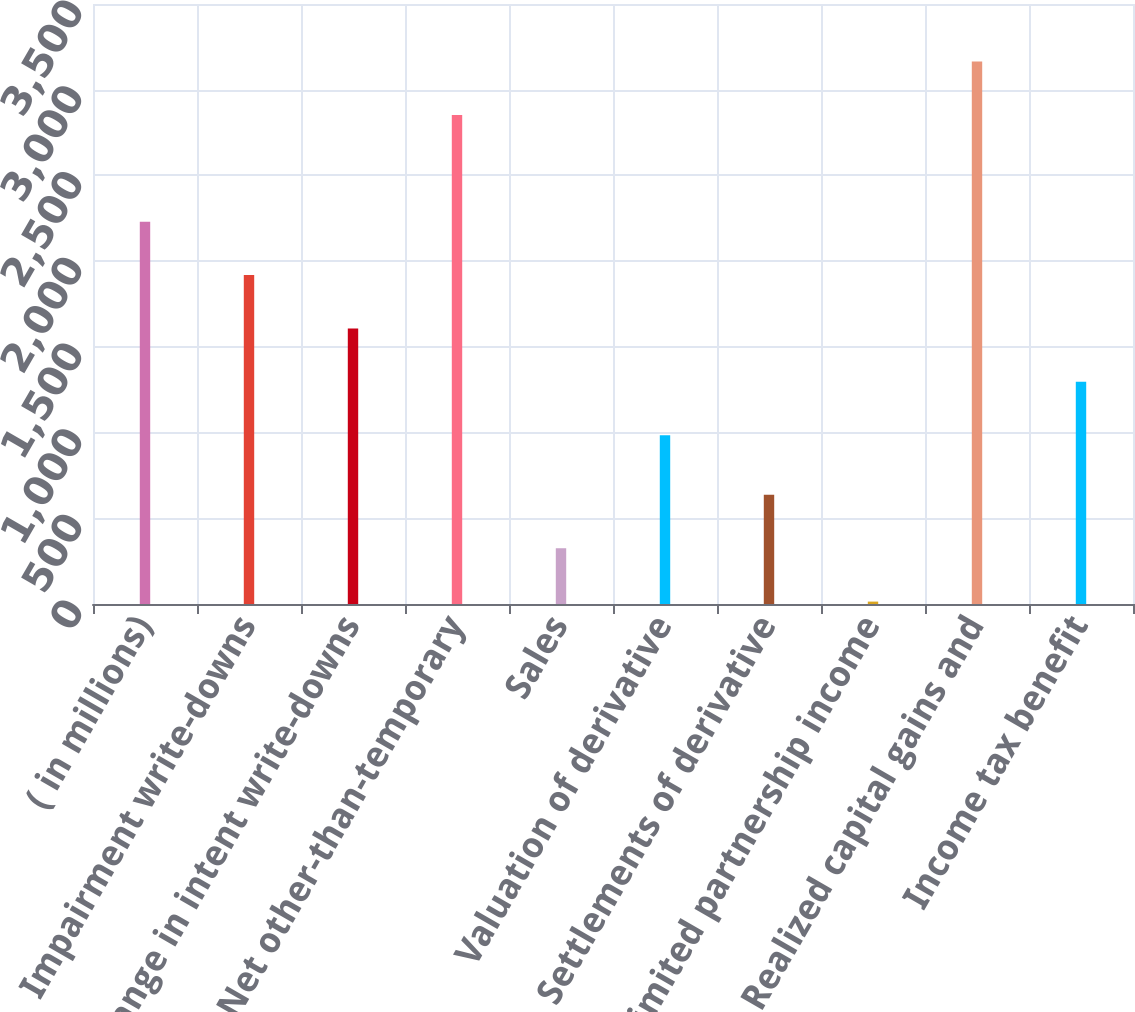Convert chart. <chart><loc_0><loc_0><loc_500><loc_500><bar_chart><fcel>( in millions)<fcel>Impairment write-downs<fcel>Change in intent write-downs<fcel>Net other-than-temporary<fcel>Sales<fcel>Valuation of derivative<fcel>Settlements of derivative<fcel>EMA limited partnership income<fcel>Realized capital gains and<fcel>Income tax benefit<nl><fcel>2230.2<fcel>1918.9<fcel>1607.6<fcel>2852.8<fcel>325.3<fcel>985<fcel>636.6<fcel>14<fcel>3164.1<fcel>1296.3<nl></chart> 